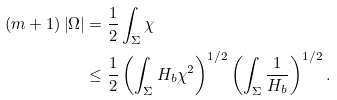Convert formula to latex. <formula><loc_0><loc_0><loc_500><loc_500>\left ( m + 1 \right ) \left | \Omega \right | & = \frac { 1 } { 2 } \int _ { \Sigma } \chi \\ & \leq \frac { 1 } { 2 } \left ( \int _ { \Sigma } H _ { b } \chi ^ { 2 } \right ) ^ { 1 / 2 } \left ( \int _ { \Sigma } \frac { 1 } { H _ { b } } \right ) ^ { 1 / 2 } .</formula> 